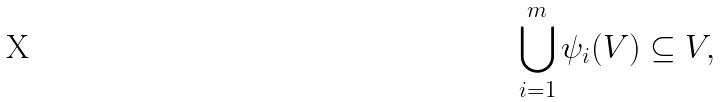<formula> <loc_0><loc_0><loc_500><loc_500>\bigcup _ { i = 1 } ^ { m } \psi _ { i } ( V ) \subseteq V ,</formula> 